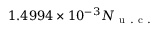<formula> <loc_0><loc_0><loc_500><loc_500>1 . 4 9 9 4 \times 1 0 ^ { - 3 } N _ { u . c . }</formula> 